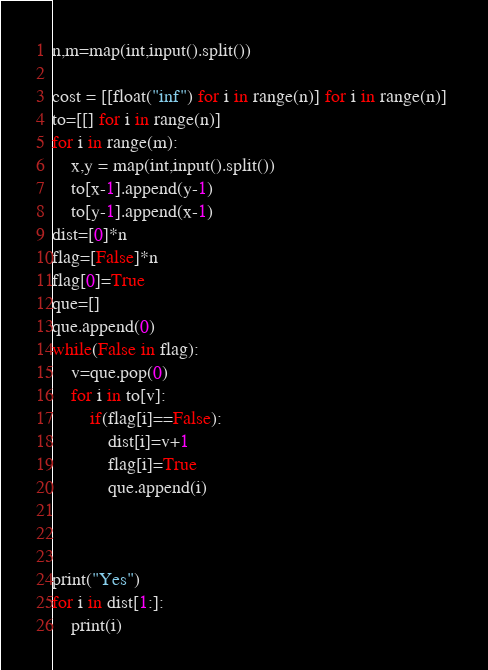<code> <loc_0><loc_0><loc_500><loc_500><_Python_>n,m=map(int,input().split())

cost = [[float("inf") for i in range(n)] for i in range(n)] 
to=[[] for i in range(n)]
for i in range(m):
    x,y = map(int,input().split())
    to[x-1].append(y-1)
    to[y-1].append(x-1)
dist=[0]*n    
flag=[False]*n
flag[0]=True
que=[]
que.append(0)
while(False in flag):
    v=que.pop(0)
    for i in to[v]:
        if(flag[i]==False):
            dist[i]=v+1
            flag[i]=True
            que.append(i)
        


print("Yes")
for i in dist[1:]:
    print(i)    
</code> 